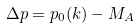Convert formula to latex. <formula><loc_0><loc_0><loc_500><loc_500>\Delta p = p _ { 0 } ( { k } ) - M _ { A }</formula> 